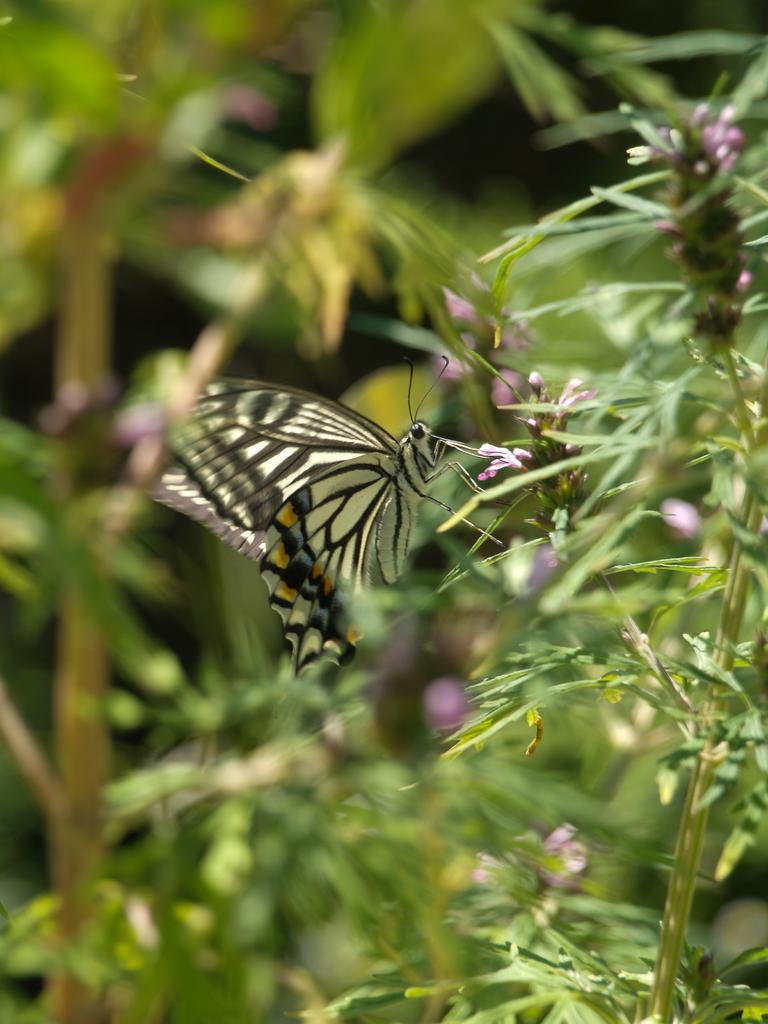What type of living organisms can be seen in the image? Plants and a butterfly can be seen in the image. Can you describe the butterfly in the image? The butterfly in the image is likely a colorful insect with wings. What type of musical instrument is being played by the butterfly in the image? There is no musical instrument present in the image, and the butterfly is not playing any instrument. 